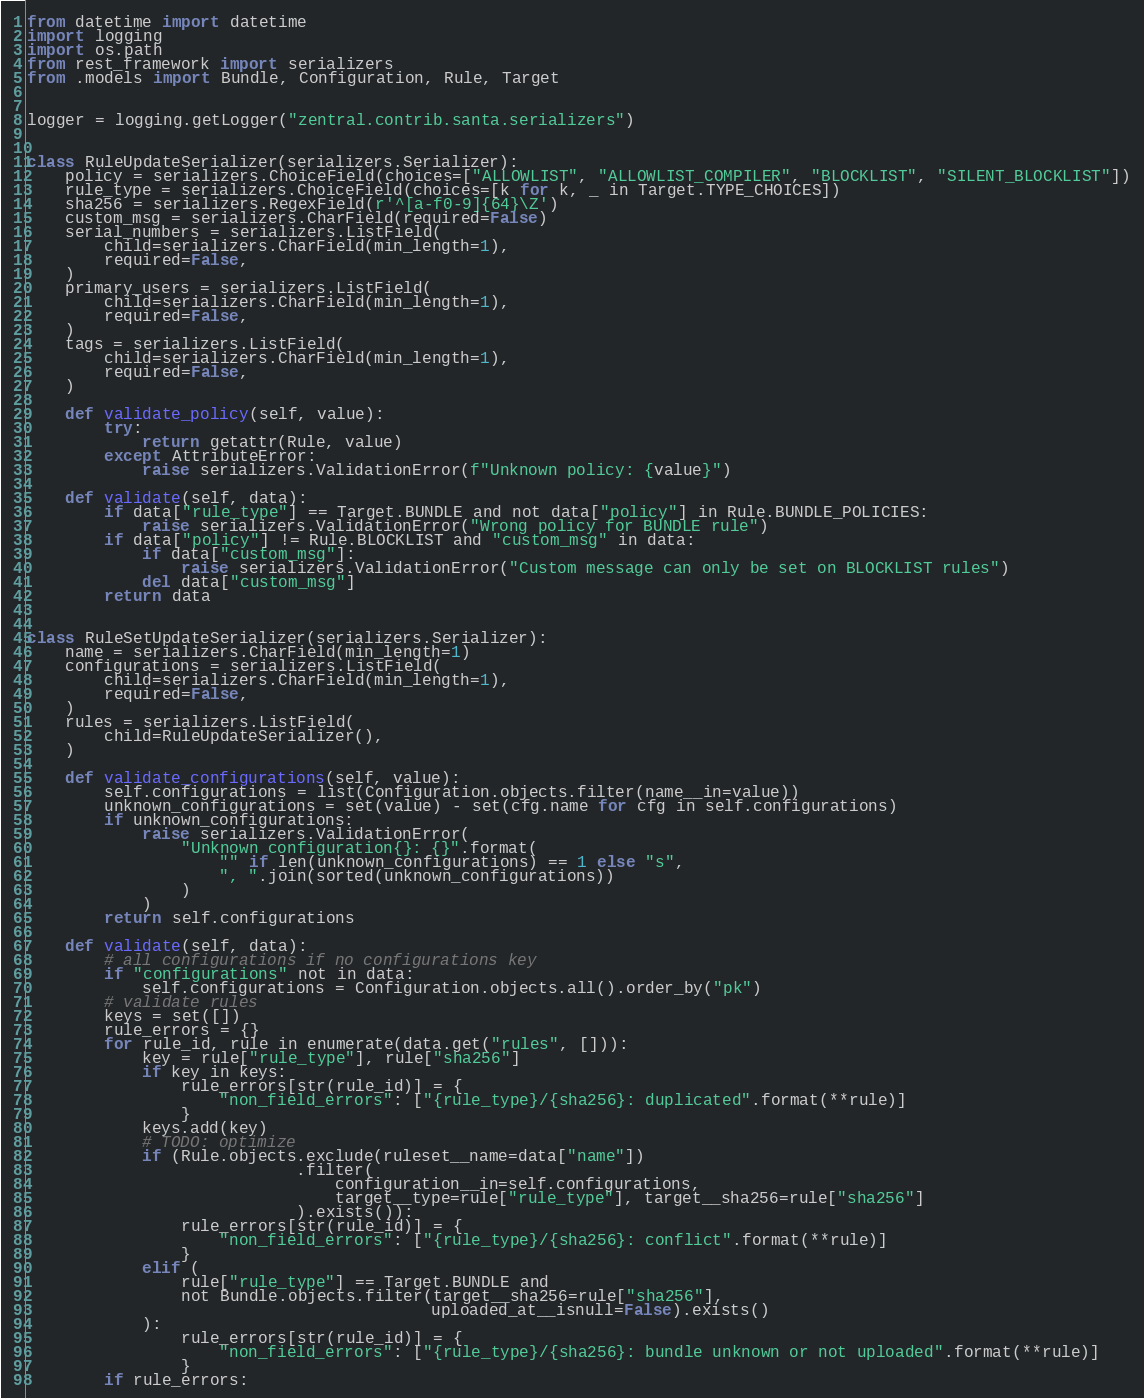<code> <loc_0><loc_0><loc_500><loc_500><_Python_>from datetime import datetime
import logging
import os.path
from rest_framework import serializers
from .models import Bundle, Configuration, Rule, Target


logger = logging.getLogger("zentral.contrib.santa.serializers")


class RuleUpdateSerializer(serializers.Serializer):
    policy = serializers.ChoiceField(choices=["ALLOWLIST", "ALLOWLIST_COMPILER", "BLOCKLIST", "SILENT_BLOCKLIST"])
    rule_type = serializers.ChoiceField(choices=[k for k, _ in Target.TYPE_CHOICES])
    sha256 = serializers.RegexField(r'^[a-f0-9]{64}\Z')
    custom_msg = serializers.CharField(required=False)
    serial_numbers = serializers.ListField(
        child=serializers.CharField(min_length=1),
        required=False,
    )
    primary_users = serializers.ListField(
        child=serializers.CharField(min_length=1),
        required=False,
    )
    tags = serializers.ListField(
        child=serializers.CharField(min_length=1),
        required=False,
    )

    def validate_policy(self, value):
        try:
            return getattr(Rule, value)
        except AttributeError:
            raise serializers.ValidationError(f"Unknown policy: {value}")

    def validate(self, data):
        if data["rule_type"] == Target.BUNDLE and not data["policy"] in Rule.BUNDLE_POLICIES:
            raise serializers.ValidationError("Wrong policy for BUNDLE rule")
        if data["policy"] != Rule.BLOCKLIST and "custom_msg" in data:
            if data["custom_msg"]:
                raise serializers.ValidationError("Custom message can only be set on BLOCKLIST rules")
            del data["custom_msg"]
        return data


class RuleSetUpdateSerializer(serializers.Serializer):
    name = serializers.CharField(min_length=1)
    configurations = serializers.ListField(
        child=serializers.CharField(min_length=1),
        required=False,
    )
    rules = serializers.ListField(
        child=RuleUpdateSerializer(),
    )

    def validate_configurations(self, value):
        self.configurations = list(Configuration.objects.filter(name__in=value))
        unknown_configurations = set(value) - set(cfg.name for cfg in self.configurations)
        if unknown_configurations:
            raise serializers.ValidationError(
                "Unknown configuration{}: {}".format(
                    "" if len(unknown_configurations) == 1 else "s",
                    ", ".join(sorted(unknown_configurations))
                )
            )
        return self.configurations

    def validate(self, data):
        # all configurations if no configurations key
        if "configurations" not in data:
            self.configurations = Configuration.objects.all().order_by("pk")
        # validate rules
        keys = set([])
        rule_errors = {}
        for rule_id, rule in enumerate(data.get("rules", [])):
            key = rule["rule_type"], rule["sha256"]
            if key in keys:
                rule_errors[str(rule_id)] = {
                    "non_field_errors": ["{rule_type}/{sha256}: duplicated".format(**rule)]
                }
            keys.add(key)
            # TODO: optimize
            if (Rule.objects.exclude(ruleset__name=data["name"])
                            .filter(
                                configuration__in=self.configurations,
                                target__type=rule["rule_type"], target__sha256=rule["sha256"]
                            ).exists()):
                rule_errors[str(rule_id)] = {
                    "non_field_errors": ["{rule_type}/{sha256}: conflict".format(**rule)]
                }
            elif (
                rule["rule_type"] == Target.BUNDLE and
                not Bundle.objects.filter(target__sha256=rule["sha256"],
                                          uploaded_at__isnull=False).exists()
            ):
                rule_errors[str(rule_id)] = {
                    "non_field_errors": ["{rule_type}/{sha256}: bundle unknown or not uploaded".format(**rule)]
                }
        if rule_errors:</code> 